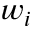Convert formula to latex. <formula><loc_0><loc_0><loc_500><loc_500>w _ { i }</formula> 